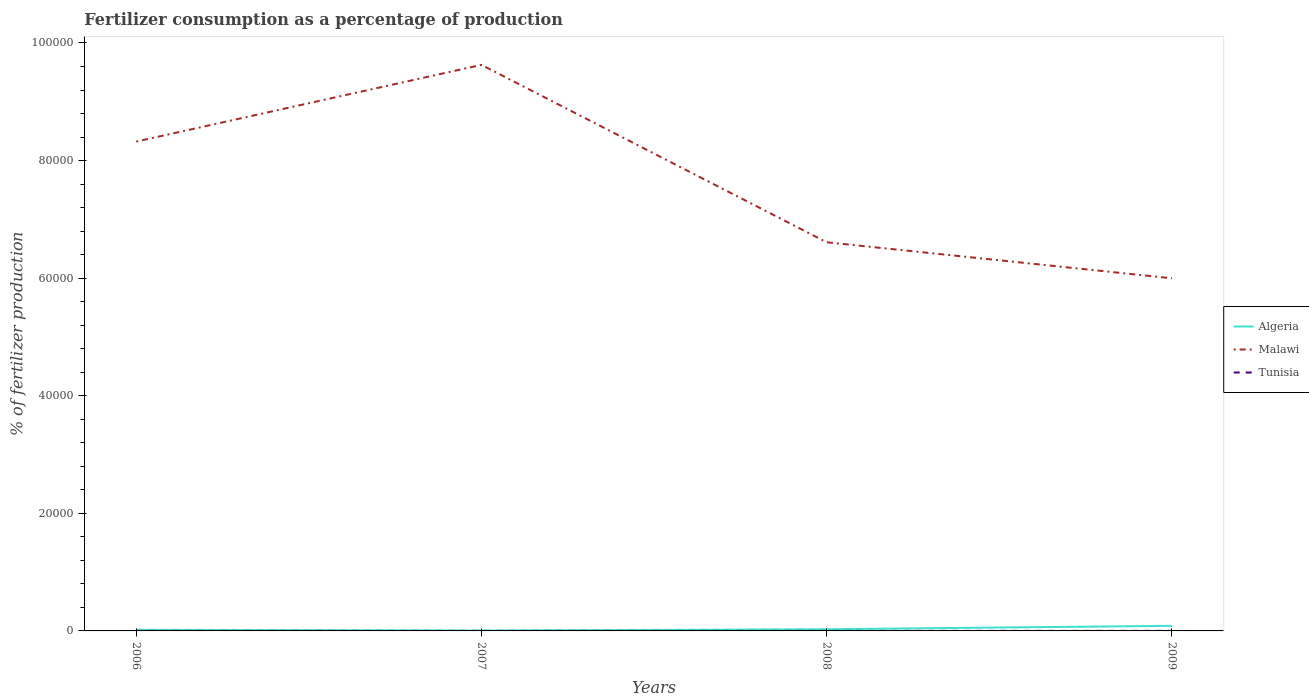How many different coloured lines are there?
Make the answer very short. 3. Is the number of lines equal to the number of legend labels?
Give a very brief answer. Yes. Across all years, what is the maximum percentage of fertilizers consumed in Malawi?
Your answer should be compact. 6.00e+04. In which year was the percentage of fertilizers consumed in Algeria maximum?
Ensure brevity in your answer.  2007. What is the total percentage of fertilizers consumed in Algeria in the graph?
Your answer should be compact. -92.51. What is the difference between the highest and the second highest percentage of fertilizers consumed in Malawi?
Make the answer very short. 3.63e+04. What is the difference between the highest and the lowest percentage of fertilizers consumed in Algeria?
Provide a succinct answer. 1. What is the difference between two consecutive major ticks on the Y-axis?
Your answer should be very brief. 2.00e+04. How many legend labels are there?
Give a very brief answer. 3. What is the title of the graph?
Make the answer very short. Fertilizer consumption as a percentage of production. What is the label or title of the Y-axis?
Provide a short and direct response. % of fertilizer production. What is the % of fertilizer production in Algeria in 2006?
Offer a very short reply. 191.44. What is the % of fertilizer production in Malawi in 2006?
Your response must be concise. 8.32e+04. What is the % of fertilizer production of Tunisia in 2006?
Provide a short and direct response. 8.41. What is the % of fertilizer production in Algeria in 2007?
Your answer should be very brief. 61.95. What is the % of fertilizer production in Malawi in 2007?
Your answer should be compact. 9.63e+04. What is the % of fertilizer production in Tunisia in 2007?
Make the answer very short. 7.13. What is the % of fertilizer production in Algeria in 2008?
Offer a terse response. 283.96. What is the % of fertilizer production in Malawi in 2008?
Your answer should be very brief. 6.61e+04. What is the % of fertilizer production of Tunisia in 2008?
Ensure brevity in your answer.  8.99. What is the % of fertilizer production of Algeria in 2009?
Provide a succinct answer. 869. What is the % of fertilizer production of Malawi in 2009?
Give a very brief answer. 6.00e+04. What is the % of fertilizer production in Tunisia in 2009?
Your answer should be compact. 10.66. Across all years, what is the maximum % of fertilizer production of Algeria?
Your response must be concise. 869. Across all years, what is the maximum % of fertilizer production of Malawi?
Your answer should be very brief. 9.63e+04. Across all years, what is the maximum % of fertilizer production in Tunisia?
Offer a very short reply. 10.66. Across all years, what is the minimum % of fertilizer production in Algeria?
Provide a short and direct response. 61.95. Across all years, what is the minimum % of fertilizer production of Malawi?
Offer a very short reply. 6.00e+04. Across all years, what is the minimum % of fertilizer production of Tunisia?
Make the answer very short. 7.13. What is the total % of fertilizer production of Algeria in the graph?
Your answer should be very brief. 1406.35. What is the total % of fertilizer production of Malawi in the graph?
Keep it short and to the point. 3.06e+05. What is the total % of fertilizer production of Tunisia in the graph?
Your response must be concise. 35.18. What is the difference between the % of fertilizer production in Algeria in 2006 and that in 2007?
Ensure brevity in your answer.  129.5. What is the difference between the % of fertilizer production of Malawi in 2006 and that in 2007?
Your answer should be compact. -1.30e+04. What is the difference between the % of fertilizer production in Tunisia in 2006 and that in 2007?
Provide a short and direct response. 1.28. What is the difference between the % of fertilizer production in Algeria in 2006 and that in 2008?
Your response must be concise. -92.51. What is the difference between the % of fertilizer production in Malawi in 2006 and that in 2008?
Provide a succinct answer. 1.71e+04. What is the difference between the % of fertilizer production of Tunisia in 2006 and that in 2008?
Offer a terse response. -0.57. What is the difference between the % of fertilizer production in Algeria in 2006 and that in 2009?
Keep it short and to the point. -677.56. What is the difference between the % of fertilizer production of Malawi in 2006 and that in 2009?
Offer a very short reply. 2.33e+04. What is the difference between the % of fertilizer production of Tunisia in 2006 and that in 2009?
Give a very brief answer. -2.24. What is the difference between the % of fertilizer production in Algeria in 2007 and that in 2008?
Offer a terse response. -222.01. What is the difference between the % of fertilizer production of Malawi in 2007 and that in 2008?
Your response must be concise. 3.02e+04. What is the difference between the % of fertilizer production in Tunisia in 2007 and that in 2008?
Make the answer very short. -1.86. What is the difference between the % of fertilizer production in Algeria in 2007 and that in 2009?
Your answer should be compact. -807.06. What is the difference between the % of fertilizer production of Malawi in 2007 and that in 2009?
Offer a very short reply. 3.63e+04. What is the difference between the % of fertilizer production in Tunisia in 2007 and that in 2009?
Your answer should be very brief. -3.53. What is the difference between the % of fertilizer production in Algeria in 2008 and that in 2009?
Your response must be concise. -585.05. What is the difference between the % of fertilizer production of Malawi in 2008 and that in 2009?
Make the answer very short. 6122.77. What is the difference between the % of fertilizer production in Tunisia in 2008 and that in 2009?
Your answer should be very brief. -1.67. What is the difference between the % of fertilizer production of Algeria in 2006 and the % of fertilizer production of Malawi in 2007?
Provide a short and direct response. -9.61e+04. What is the difference between the % of fertilizer production in Algeria in 2006 and the % of fertilizer production in Tunisia in 2007?
Offer a very short reply. 184.31. What is the difference between the % of fertilizer production in Malawi in 2006 and the % of fertilizer production in Tunisia in 2007?
Provide a short and direct response. 8.32e+04. What is the difference between the % of fertilizer production of Algeria in 2006 and the % of fertilizer production of Malawi in 2008?
Keep it short and to the point. -6.59e+04. What is the difference between the % of fertilizer production in Algeria in 2006 and the % of fertilizer production in Tunisia in 2008?
Offer a very short reply. 182.46. What is the difference between the % of fertilizer production of Malawi in 2006 and the % of fertilizer production of Tunisia in 2008?
Ensure brevity in your answer.  8.32e+04. What is the difference between the % of fertilizer production in Algeria in 2006 and the % of fertilizer production in Malawi in 2009?
Ensure brevity in your answer.  -5.98e+04. What is the difference between the % of fertilizer production in Algeria in 2006 and the % of fertilizer production in Tunisia in 2009?
Your answer should be very brief. 180.79. What is the difference between the % of fertilizer production of Malawi in 2006 and the % of fertilizer production of Tunisia in 2009?
Give a very brief answer. 8.32e+04. What is the difference between the % of fertilizer production of Algeria in 2007 and the % of fertilizer production of Malawi in 2008?
Give a very brief answer. -6.60e+04. What is the difference between the % of fertilizer production of Algeria in 2007 and the % of fertilizer production of Tunisia in 2008?
Offer a terse response. 52.96. What is the difference between the % of fertilizer production of Malawi in 2007 and the % of fertilizer production of Tunisia in 2008?
Your answer should be very brief. 9.63e+04. What is the difference between the % of fertilizer production of Algeria in 2007 and the % of fertilizer production of Malawi in 2009?
Offer a very short reply. -5.99e+04. What is the difference between the % of fertilizer production in Algeria in 2007 and the % of fertilizer production in Tunisia in 2009?
Your answer should be compact. 51.29. What is the difference between the % of fertilizer production of Malawi in 2007 and the % of fertilizer production of Tunisia in 2009?
Your answer should be very brief. 9.63e+04. What is the difference between the % of fertilizer production in Algeria in 2008 and the % of fertilizer production in Malawi in 2009?
Provide a short and direct response. -5.97e+04. What is the difference between the % of fertilizer production in Algeria in 2008 and the % of fertilizer production in Tunisia in 2009?
Provide a short and direct response. 273.3. What is the difference between the % of fertilizer production in Malawi in 2008 and the % of fertilizer production in Tunisia in 2009?
Give a very brief answer. 6.61e+04. What is the average % of fertilizer production in Algeria per year?
Provide a short and direct response. 351.59. What is the average % of fertilizer production of Malawi per year?
Your answer should be very brief. 7.64e+04. What is the average % of fertilizer production in Tunisia per year?
Give a very brief answer. 8.8. In the year 2006, what is the difference between the % of fertilizer production in Algeria and % of fertilizer production in Malawi?
Make the answer very short. -8.30e+04. In the year 2006, what is the difference between the % of fertilizer production of Algeria and % of fertilizer production of Tunisia?
Offer a very short reply. 183.03. In the year 2006, what is the difference between the % of fertilizer production of Malawi and % of fertilizer production of Tunisia?
Offer a very short reply. 8.32e+04. In the year 2007, what is the difference between the % of fertilizer production of Algeria and % of fertilizer production of Malawi?
Your answer should be compact. -9.62e+04. In the year 2007, what is the difference between the % of fertilizer production of Algeria and % of fertilizer production of Tunisia?
Offer a terse response. 54.82. In the year 2007, what is the difference between the % of fertilizer production of Malawi and % of fertilizer production of Tunisia?
Offer a terse response. 9.63e+04. In the year 2008, what is the difference between the % of fertilizer production in Algeria and % of fertilizer production in Malawi?
Your answer should be very brief. -6.58e+04. In the year 2008, what is the difference between the % of fertilizer production of Algeria and % of fertilizer production of Tunisia?
Your answer should be compact. 274.97. In the year 2008, what is the difference between the % of fertilizer production in Malawi and % of fertilizer production in Tunisia?
Give a very brief answer. 6.61e+04. In the year 2009, what is the difference between the % of fertilizer production in Algeria and % of fertilizer production in Malawi?
Provide a short and direct response. -5.91e+04. In the year 2009, what is the difference between the % of fertilizer production in Algeria and % of fertilizer production in Tunisia?
Ensure brevity in your answer.  858.35. In the year 2009, what is the difference between the % of fertilizer production of Malawi and % of fertilizer production of Tunisia?
Give a very brief answer. 6.00e+04. What is the ratio of the % of fertilizer production in Algeria in 2006 to that in 2007?
Make the answer very short. 3.09. What is the ratio of the % of fertilizer production of Malawi in 2006 to that in 2007?
Provide a succinct answer. 0.86. What is the ratio of the % of fertilizer production of Tunisia in 2006 to that in 2007?
Make the answer very short. 1.18. What is the ratio of the % of fertilizer production in Algeria in 2006 to that in 2008?
Offer a very short reply. 0.67. What is the ratio of the % of fertilizer production in Malawi in 2006 to that in 2008?
Offer a very short reply. 1.26. What is the ratio of the % of fertilizer production of Tunisia in 2006 to that in 2008?
Make the answer very short. 0.94. What is the ratio of the % of fertilizer production of Algeria in 2006 to that in 2009?
Provide a short and direct response. 0.22. What is the ratio of the % of fertilizer production of Malawi in 2006 to that in 2009?
Offer a very short reply. 1.39. What is the ratio of the % of fertilizer production of Tunisia in 2006 to that in 2009?
Keep it short and to the point. 0.79. What is the ratio of the % of fertilizer production of Algeria in 2007 to that in 2008?
Offer a terse response. 0.22. What is the ratio of the % of fertilizer production in Malawi in 2007 to that in 2008?
Your answer should be very brief. 1.46. What is the ratio of the % of fertilizer production in Tunisia in 2007 to that in 2008?
Provide a short and direct response. 0.79. What is the ratio of the % of fertilizer production of Algeria in 2007 to that in 2009?
Provide a succinct answer. 0.07. What is the ratio of the % of fertilizer production in Malawi in 2007 to that in 2009?
Provide a succinct answer. 1.61. What is the ratio of the % of fertilizer production of Tunisia in 2007 to that in 2009?
Make the answer very short. 0.67. What is the ratio of the % of fertilizer production in Algeria in 2008 to that in 2009?
Your answer should be compact. 0.33. What is the ratio of the % of fertilizer production in Malawi in 2008 to that in 2009?
Your answer should be compact. 1.1. What is the ratio of the % of fertilizer production of Tunisia in 2008 to that in 2009?
Your response must be concise. 0.84. What is the difference between the highest and the second highest % of fertilizer production in Algeria?
Your response must be concise. 585.05. What is the difference between the highest and the second highest % of fertilizer production in Malawi?
Provide a short and direct response. 1.30e+04. What is the difference between the highest and the second highest % of fertilizer production in Tunisia?
Ensure brevity in your answer.  1.67. What is the difference between the highest and the lowest % of fertilizer production of Algeria?
Your answer should be compact. 807.06. What is the difference between the highest and the lowest % of fertilizer production of Malawi?
Your response must be concise. 3.63e+04. What is the difference between the highest and the lowest % of fertilizer production in Tunisia?
Ensure brevity in your answer.  3.53. 